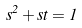Convert formula to latex. <formula><loc_0><loc_0><loc_500><loc_500>s ^ { 2 } + s t = 1</formula> 